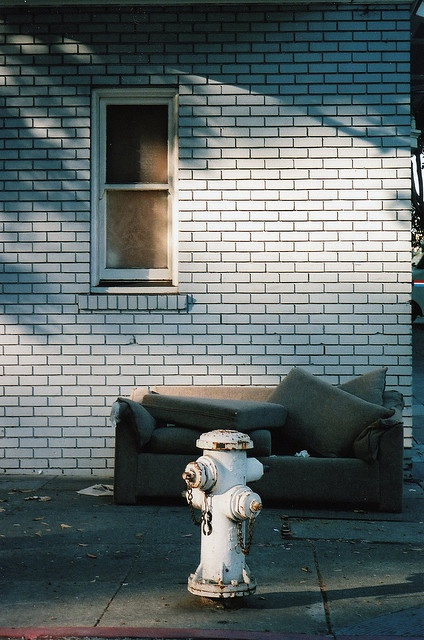Describe the objects in this image and their specific colors. I can see couch in black, gray, purple, and darkgray tones and fire hydrant in black, lightgray, darkgray, and gray tones in this image. 